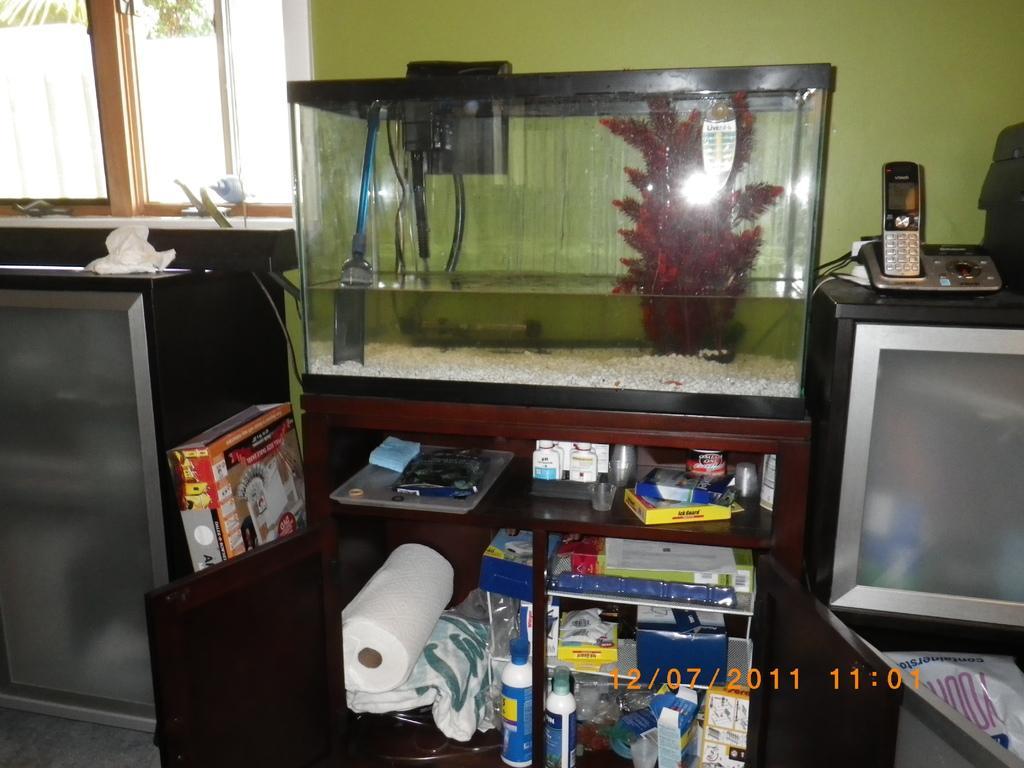Can you describe this image briefly? In this picture we can see a tissue role, bottles, boxes and some objects in the cupboard. On the cupboard there is an aquarium. On the right side of the aquarium there is a television and on top of the television there are some objects. Under the television, there is a plastic cover. On the left side of the cupboard there is an object. Behind the aquarium there's a wall and window. 